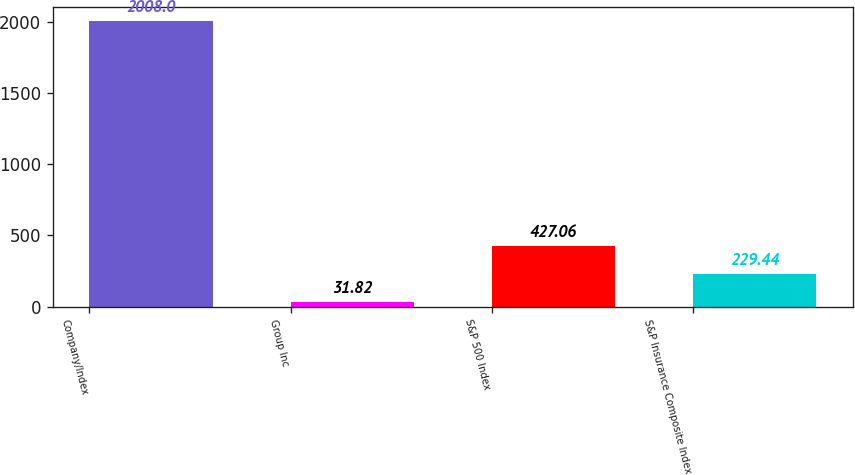<chart> <loc_0><loc_0><loc_500><loc_500><bar_chart><fcel>Company/Index<fcel>Group Inc<fcel>S&P 500 Index<fcel>S&P Insurance Composite Index<nl><fcel>2008<fcel>31.82<fcel>427.06<fcel>229.44<nl></chart> 